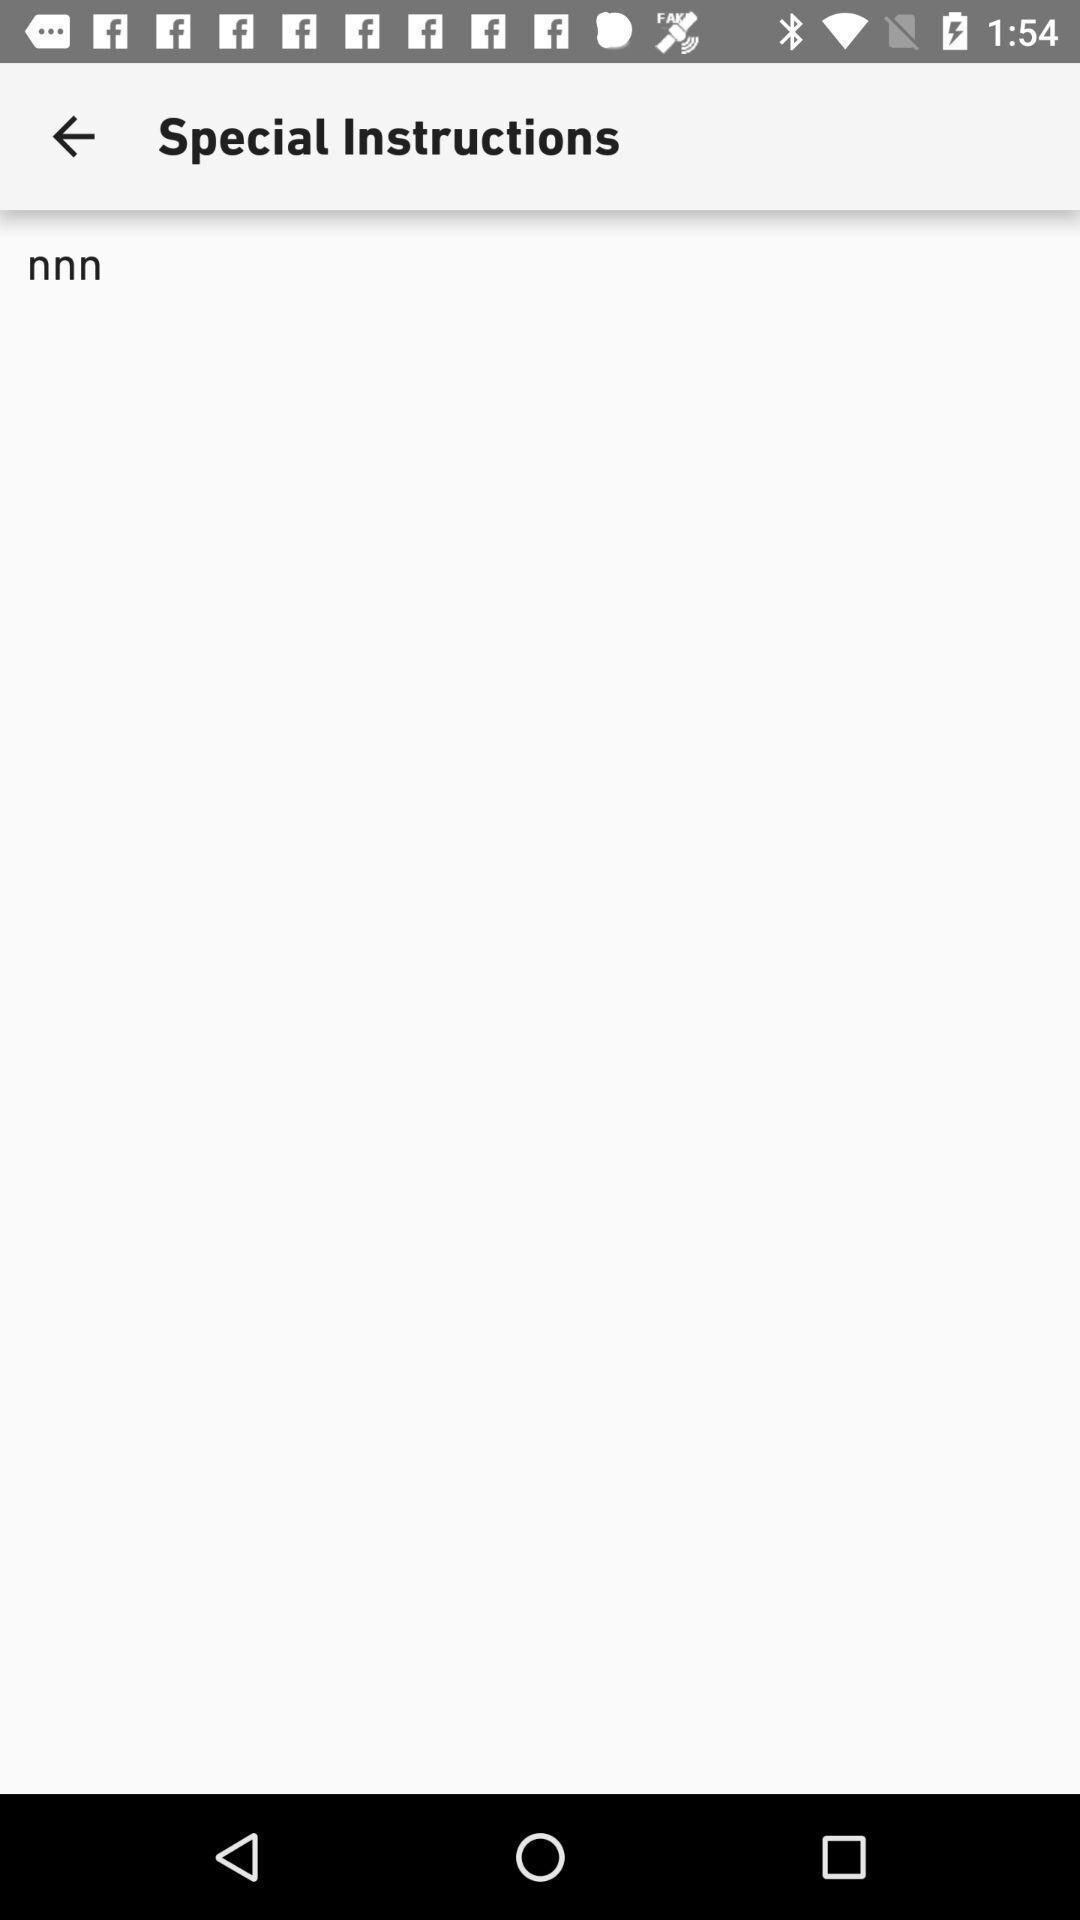Explain what's happening in this screen capture. Screen showing page. 